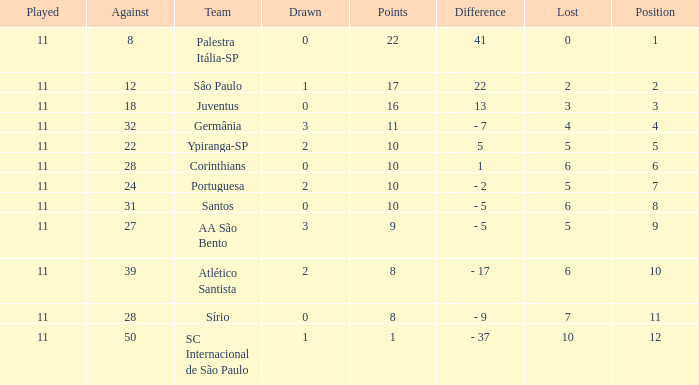What was the average Position for which the amount Drawn was less than 0? None. 